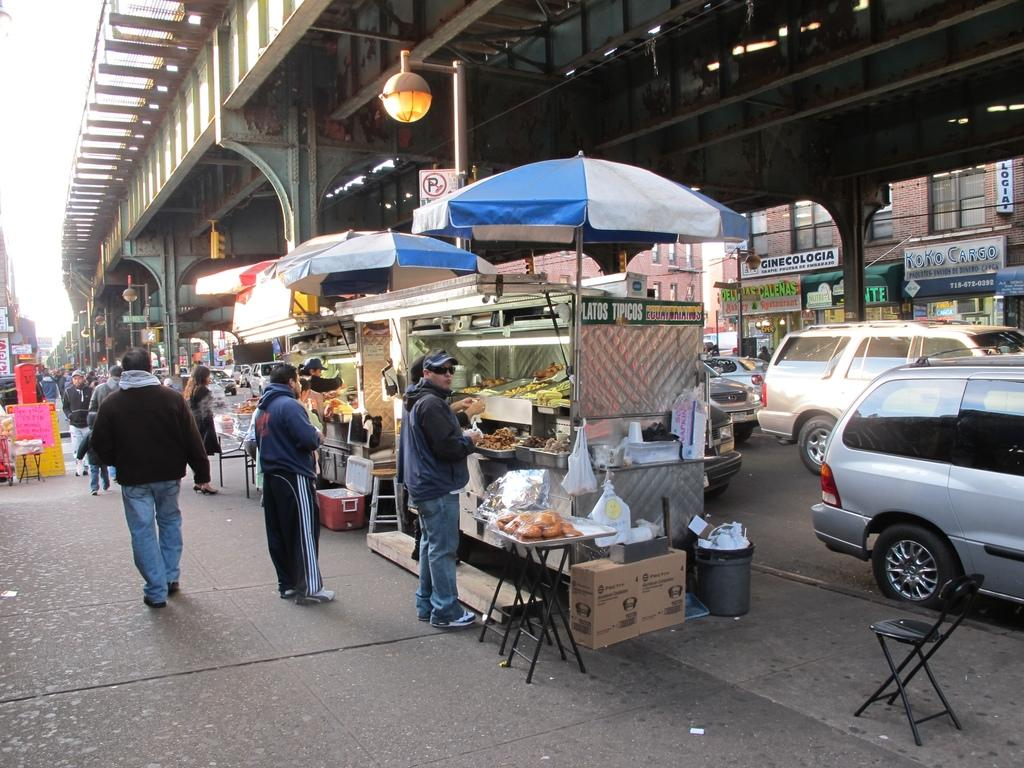What can be seen in the sky in the image? The sky is visible in the image, but no specific details are provided about its appearance. What type of structure is present in the image? There is a bridge in the image. What is used for illumination in the image? There is a street lamp in the image. What type of vehicles are on the road in the image? There are cars on the road in the image. What type of furniture is present in the image? There are chairs and a table in the image. What are the people in the image doing? There are people standing on the road in the image. What type of mountain is visible in the image? There is no mountain present in the image. What government policies are being discussed by the people standing on the road in the image? There is no indication of any discussions or policies in the image. Where is the drawer located in the image? There is no drawer present in the image. 